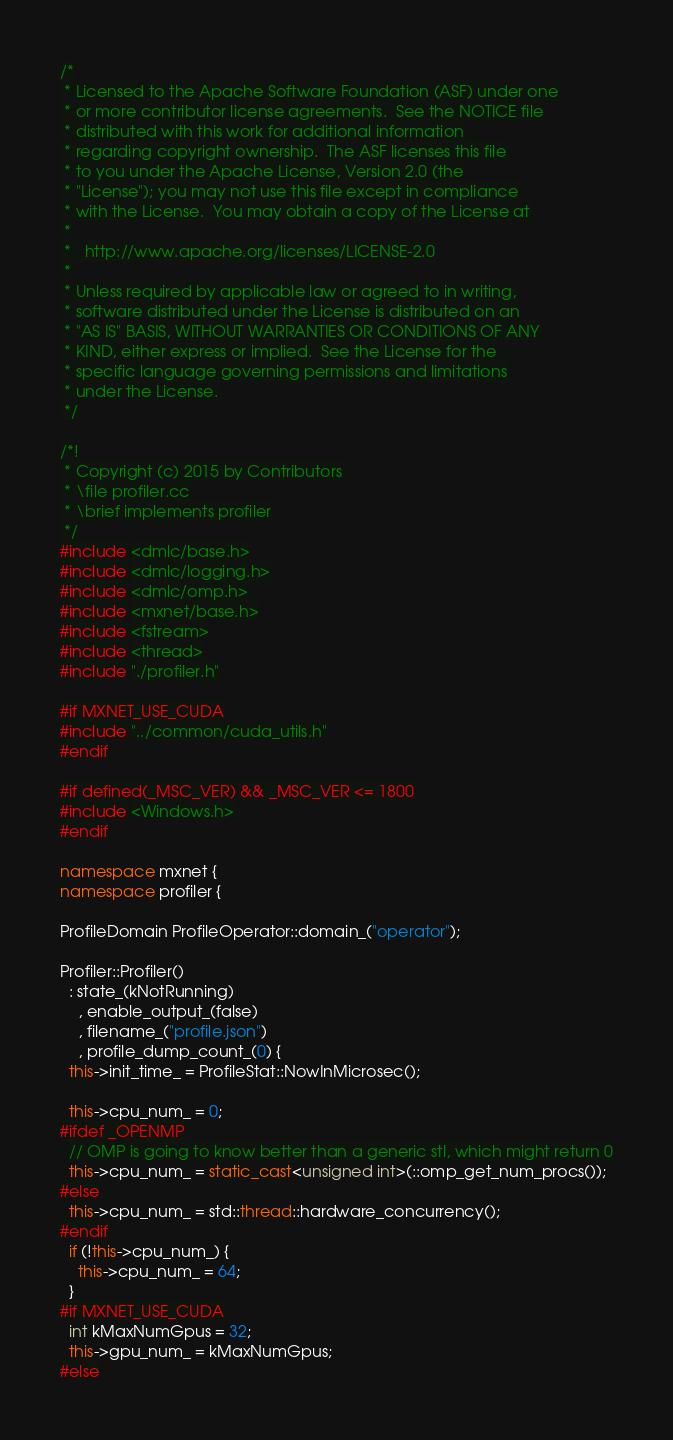Convert code to text. <code><loc_0><loc_0><loc_500><loc_500><_C++_>/*
 * Licensed to the Apache Software Foundation (ASF) under one
 * or more contributor license agreements.  See the NOTICE file
 * distributed with this work for additional information
 * regarding copyright ownership.  The ASF licenses this file
 * to you under the Apache License, Version 2.0 (the
 * "License"); you may not use this file except in compliance
 * with the License.  You may obtain a copy of the License at
 *
 *   http://www.apache.org/licenses/LICENSE-2.0
 *
 * Unless required by applicable law or agreed to in writing,
 * software distributed under the License is distributed on an
 * "AS IS" BASIS, WITHOUT WARRANTIES OR CONDITIONS OF ANY
 * KIND, either express or implied.  See the License for the
 * specific language governing permissions and limitations
 * under the License.
 */

/*!
 * Copyright (c) 2015 by Contributors
 * \file profiler.cc
 * \brief implements profiler
 */
#include <dmlc/base.h>
#include <dmlc/logging.h>
#include <dmlc/omp.h>
#include <mxnet/base.h>
#include <fstream>
#include <thread>
#include "./profiler.h"

#if MXNET_USE_CUDA
#include "../common/cuda_utils.h"
#endif

#if defined(_MSC_VER) && _MSC_VER <= 1800
#include <Windows.h>
#endif

namespace mxnet {
namespace profiler {

ProfileDomain ProfileOperator::domain_("operator");

Profiler::Profiler()
  : state_(kNotRunning)
    , enable_output_(false)
    , filename_("profile.json")
    , profile_dump_count_(0) {
  this->init_time_ = ProfileStat::NowInMicrosec();

  this->cpu_num_ = 0;
#ifdef _OPENMP
  // OMP is going to know better than a generic stl, which might return 0
  this->cpu_num_ = static_cast<unsigned int>(::omp_get_num_procs());
#else
  this->cpu_num_ = std::thread::hardware_concurrency();
#endif
  if (!this->cpu_num_) {
    this->cpu_num_ = 64;
  }
#if MXNET_USE_CUDA
  int kMaxNumGpus = 32;
  this->gpu_num_ = kMaxNumGpus;
#else</code> 